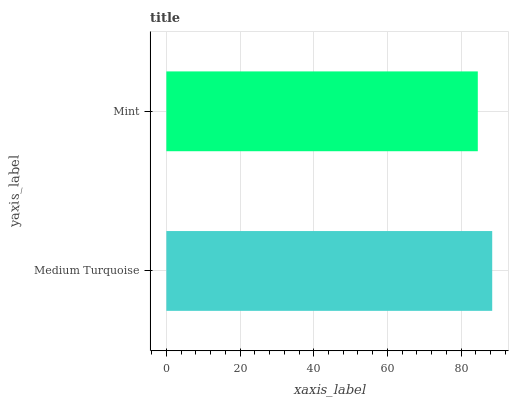Is Mint the minimum?
Answer yes or no. Yes. Is Medium Turquoise the maximum?
Answer yes or no. Yes. Is Mint the maximum?
Answer yes or no. No. Is Medium Turquoise greater than Mint?
Answer yes or no. Yes. Is Mint less than Medium Turquoise?
Answer yes or no. Yes. Is Mint greater than Medium Turquoise?
Answer yes or no. No. Is Medium Turquoise less than Mint?
Answer yes or no. No. Is Medium Turquoise the high median?
Answer yes or no. Yes. Is Mint the low median?
Answer yes or no. Yes. Is Mint the high median?
Answer yes or no. No. Is Medium Turquoise the low median?
Answer yes or no. No. 